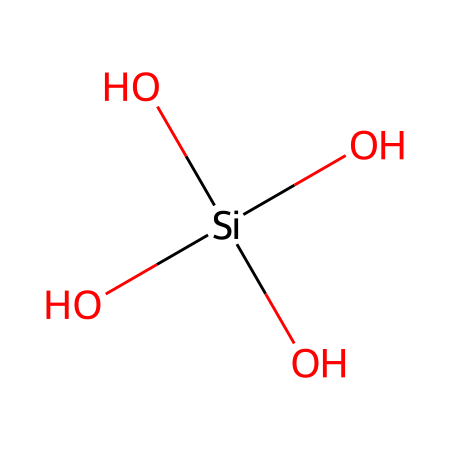How many oxygen atoms are in the compound? The SMILES notation shows four oxygen atoms represented by 'O'. Each 'O' corresponds to one oxygen atom in the structure.
Answer: four What type of chemical structure is represented? The presence of silicon and multiple oxygen groups indicates that this structure represents a silicon-containing compound with hydroxyl groups, characteristic of silica.
Answer: silica How many silicon atoms are present in the structure? There is one 'Si' in the SMILES notation, which indicates that there is one silicon atom in the chemical structure.
Answer: one What is the coordination number of the silicon atom? The silicon atom is bonded to four oxygen atoms, which means it has a coordination number of four. This indicates how many atoms are directly bonded to the silicon.
Answer: four What functional groups are present in this molecule? The molecule has hydroxyl groups (-OH) as indicated by the arrangement of three oxygen atoms directly bonded to the silicon, which signifies the presence of hydroxyl functional groups.
Answer: hydroxyl groups What is the hybridization of the silicon atom in this compound? The silicon atom is surrounded by four groups (three hydroxyl groups and one additional oxygen with single bonds), indicating it adopts a tetrahedral hybridization state (sp3).
Answer: sp3 